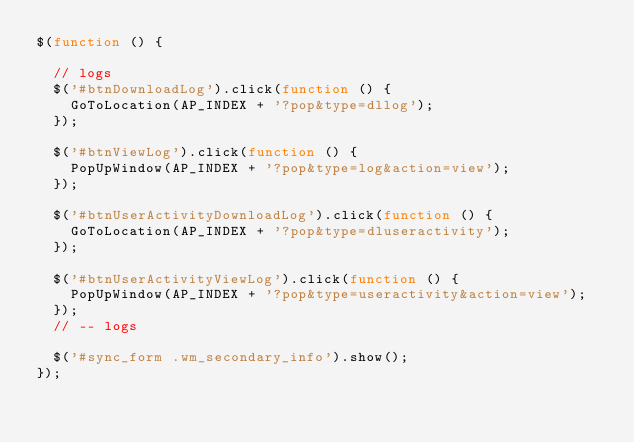<code> <loc_0><loc_0><loc_500><loc_500><_JavaScript_>$(function () {

	// logs
	$('#btnDownloadLog').click(function () {
		GoToLocation(AP_INDEX + '?pop&type=dllog');
	});

	$('#btnViewLog').click(function () {
		PopUpWindow(AP_INDEX + '?pop&type=log&action=view');
	});

	$('#btnUserActivityDownloadLog').click(function () {
		GoToLocation(AP_INDEX + '?pop&type=dluseractivity');
	});
	
	$('#btnUserActivityViewLog').click(function () {
		PopUpWindow(AP_INDEX + '?pop&type=useractivity&action=view');
	});
	// -- logs

	$('#sync_form .wm_secondary_info').show();
});</code> 